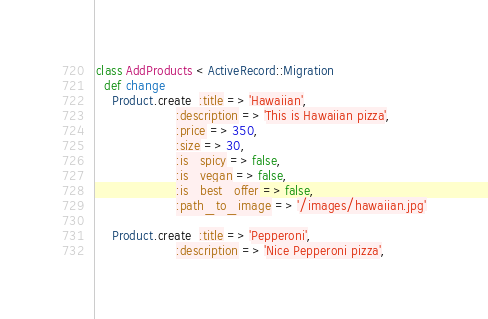<code> <loc_0><loc_0><loc_500><loc_500><_Ruby_>class AddProducts < ActiveRecord::Migration
  def change
    Product.create  :title => 'Hawaiian',
                    :description => 'This is Hawaiian pizza',
                    :price => 350,
                    :size => 30,
                    :is_spicy => false,
                    :is_vegan => false,
                    :is_best_offer => false,
                    :path_to_image => '/images/hawaiian.jpg'

    Product.create  :title => 'Pepperoni',
                    :description => 'Nice Pepperoni pizza',</code> 